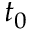<formula> <loc_0><loc_0><loc_500><loc_500>t _ { 0 }</formula> 